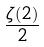Convert formula to latex. <formula><loc_0><loc_0><loc_500><loc_500>\frac { \zeta ( 2 ) } { 2 }</formula> 